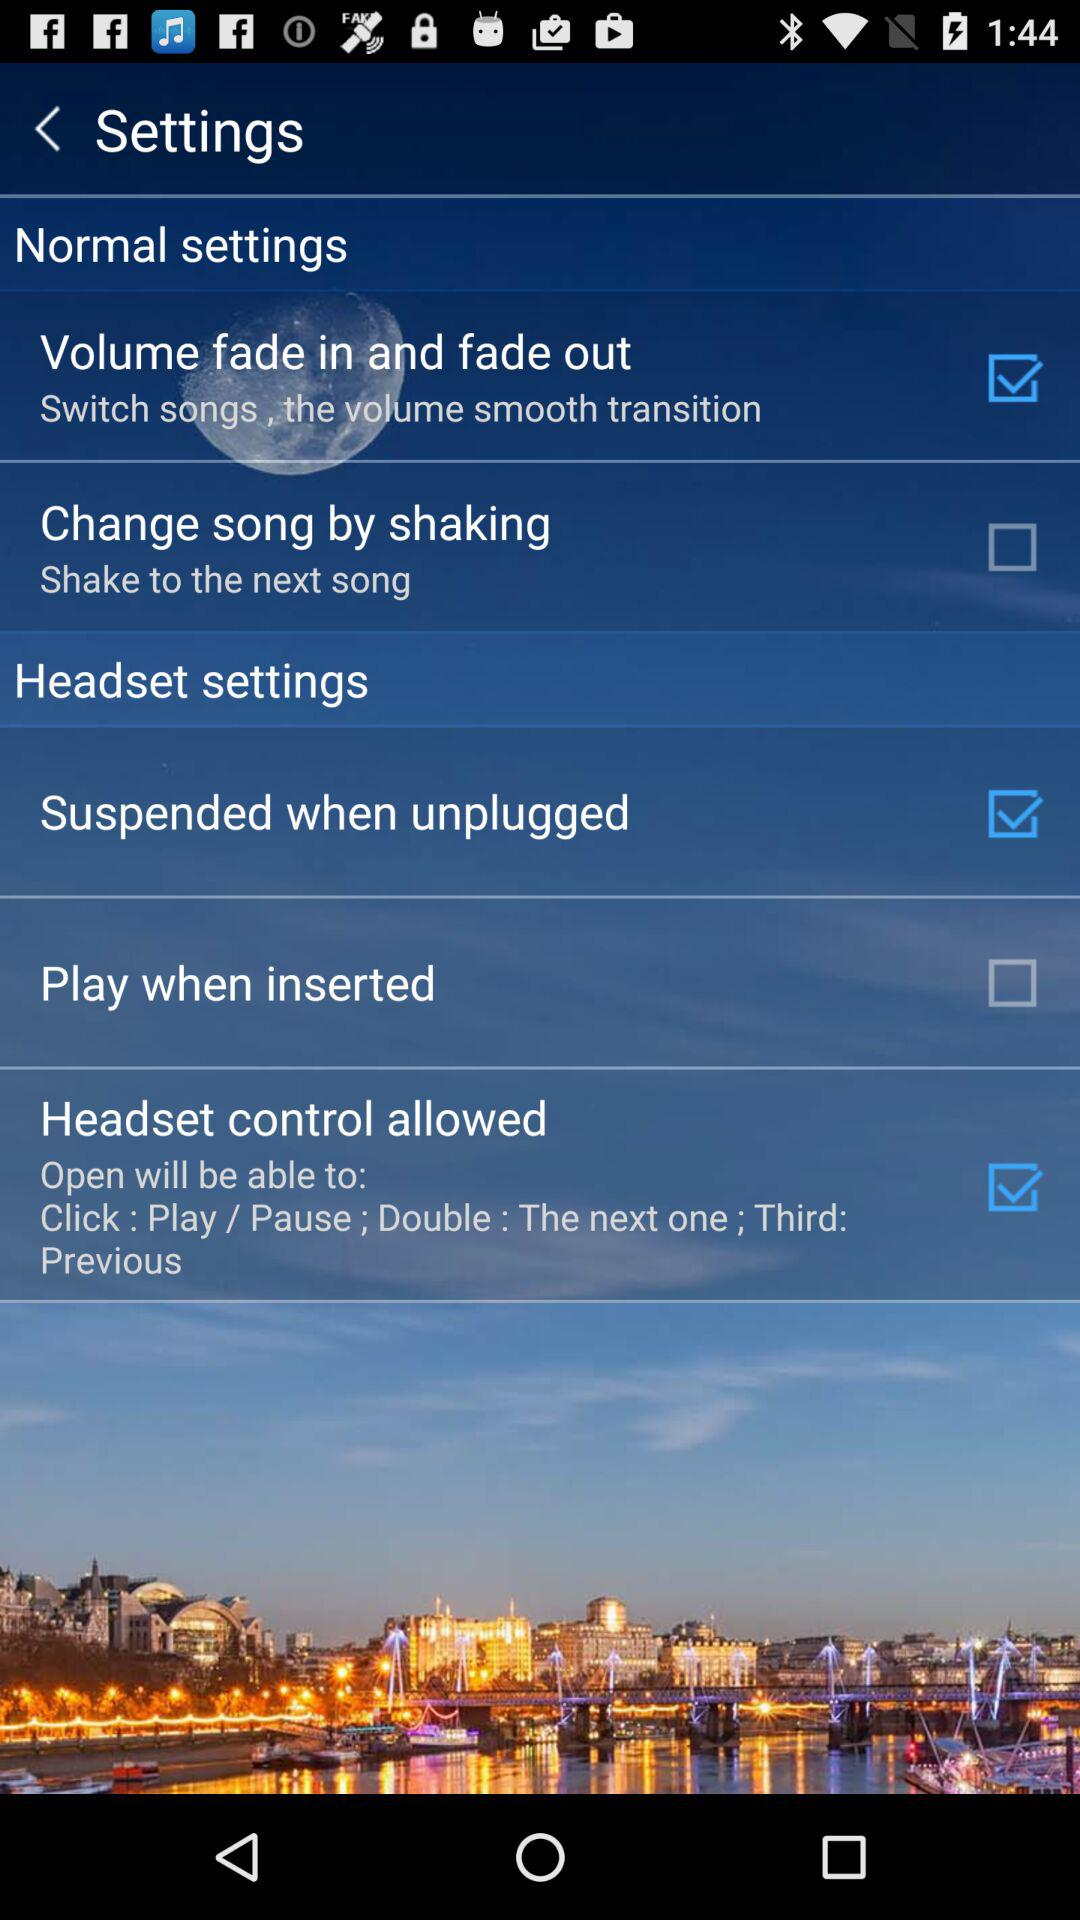What is the current status of "Suspended when unplugged"? The current status is "on". 